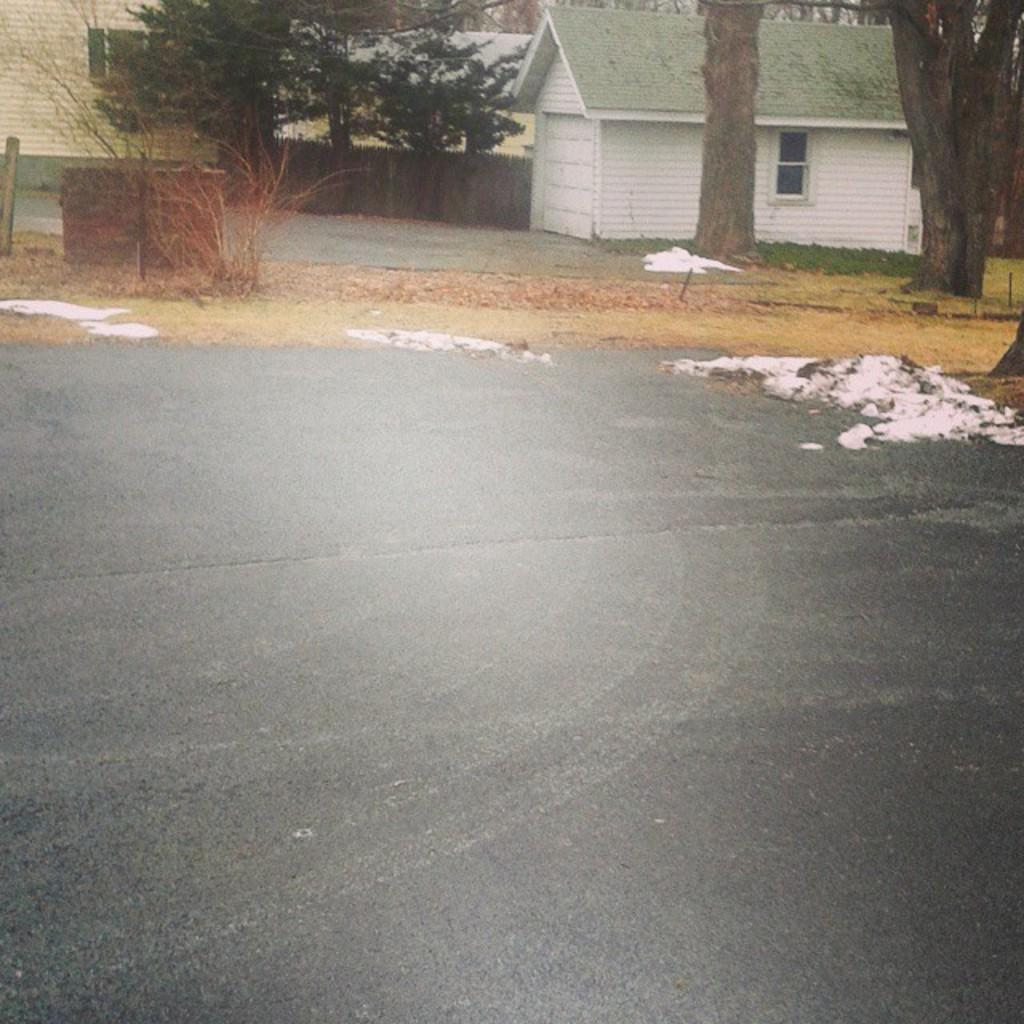What type of structures can be seen in the image? There are sheds in the image. What type of vegetation is present in the image? There are trees and plants in the image. What is the tall, vertical object in the image? There is a pole in the image. What type of barrier is visible in the image? There is a wall in the image. What is the condition of the road in the image? There is snow on the road in the image. Can you tell me the opinion of the bottle in the image? There is no bottle present in the image, so it is not possible to determine its opinion. Is there a chess game being played in the image? There is no indication of a chess game or any game in the image. 